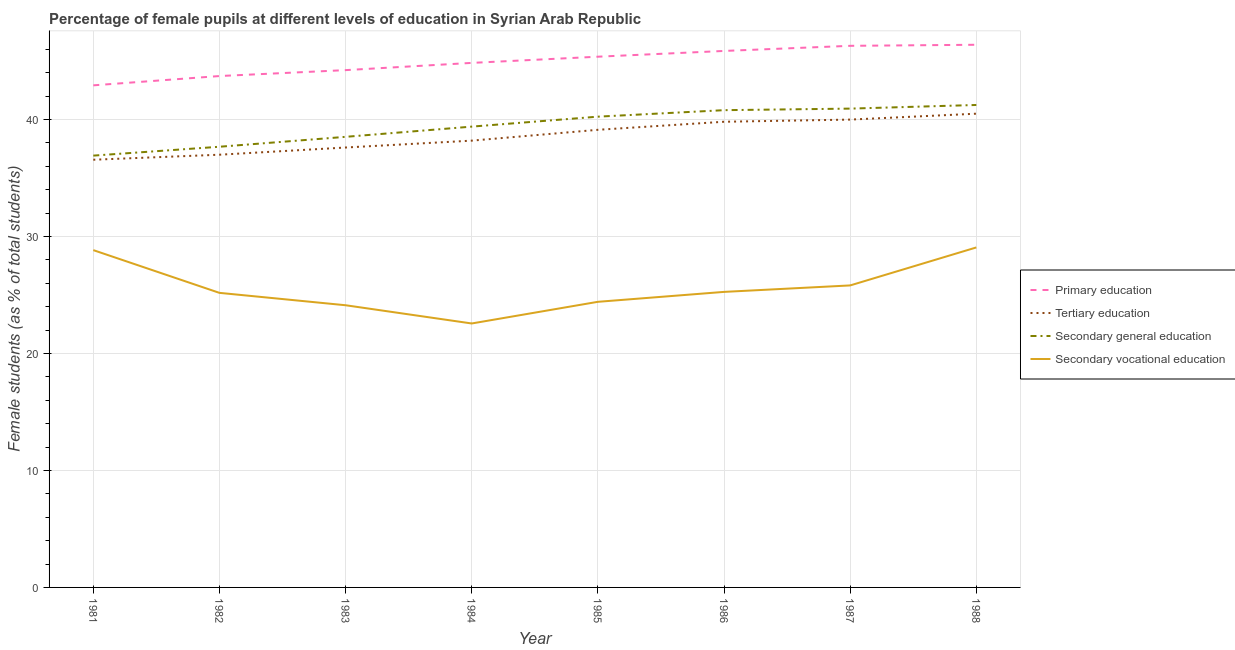Does the line corresponding to percentage of female students in primary education intersect with the line corresponding to percentage of female students in secondary vocational education?
Your answer should be very brief. No. What is the percentage of female students in tertiary education in 1981?
Your response must be concise. 36.56. Across all years, what is the maximum percentage of female students in primary education?
Your answer should be very brief. 46.39. Across all years, what is the minimum percentage of female students in primary education?
Your answer should be compact. 42.92. In which year was the percentage of female students in tertiary education maximum?
Offer a terse response. 1988. In which year was the percentage of female students in secondary vocational education minimum?
Your answer should be compact. 1984. What is the total percentage of female students in tertiary education in the graph?
Provide a succinct answer. 308.75. What is the difference between the percentage of female students in primary education in 1985 and that in 1986?
Provide a succinct answer. -0.49. What is the difference between the percentage of female students in tertiary education in 1981 and the percentage of female students in secondary education in 1987?
Ensure brevity in your answer.  -4.37. What is the average percentage of female students in primary education per year?
Offer a terse response. 44.95. In the year 1984, what is the difference between the percentage of female students in tertiary education and percentage of female students in primary education?
Your answer should be very brief. -6.65. What is the ratio of the percentage of female students in secondary education in 1983 to that in 1988?
Your response must be concise. 0.93. What is the difference between the highest and the second highest percentage of female students in tertiary education?
Offer a very short reply. 0.5. What is the difference between the highest and the lowest percentage of female students in primary education?
Your answer should be very brief. 3.47. In how many years, is the percentage of female students in tertiary education greater than the average percentage of female students in tertiary education taken over all years?
Offer a terse response. 4. Is it the case that in every year, the sum of the percentage of female students in tertiary education and percentage of female students in primary education is greater than the sum of percentage of female students in secondary education and percentage of female students in secondary vocational education?
Your answer should be very brief. No. Does the percentage of female students in secondary vocational education monotonically increase over the years?
Your answer should be compact. No. Is the percentage of female students in primary education strictly greater than the percentage of female students in secondary vocational education over the years?
Give a very brief answer. Yes. Is the percentage of female students in primary education strictly less than the percentage of female students in secondary vocational education over the years?
Ensure brevity in your answer.  No. How many lines are there?
Offer a very short reply. 4. Are the values on the major ticks of Y-axis written in scientific E-notation?
Ensure brevity in your answer.  No. How many legend labels are there?
Keep it short and to the point. 4. How are the legend labels stacked?
Keep it short and to the point. Vertical. What is the title of the graph?
Give a very brief answer. Percentage of female pupils at different levels of education in Syrian Arab Republic. What is the label or title of the X-axis?
Your answer should be compact. Year. What is the label or title of the Y-axis?
Offer a terse response. Female students (as % of total students). What is the Female students (as % of total students) in Primary education in 1981?
Provide a succinct answer. 42.92. What is the Female students (as % of total students) in Tertiary education in 1981?
Make the answer very short. 36.56. What is the Female students (as % of total students) in Secondary general education in 1981?
Provide a short and direct response. 36.91. What is the Female students (as % of total students) in Secondary vocational education in 1981?
Offer a very short reply. 28.83. What is the Female students (as % of total students) in Primary education in 1982?
Provide a short and direct response. 43.71. What is the Female students (as % of total students) in Tertiary education in 1982?
Give a very brief answer. 36.99. What is the Female students (as % of total students) in Secondary general education in 1982?
Give a very brief answer. 37.67. What is the Female students (as % of total students) in Secondary vocational education in 1982?
Give a very brief answer. 25.18. What is the Female students (as % of total students) in Primary education in 1983?
Offer a terse response. 44.22. What is the Female students (as % of total students) of Tertiary education in 1983?
Ensure brevity in your answer.  37.6. What is the Female students (as % of total students) of Secondary general education in 1983?
Provide a short and direct response. 38.52. What is the Female students (as % of total students) in Secondary vocational education in 1983?
Provide a short and direct response. 24.12. What is the Female students (as % of total students) of Primary education in 1984?
Keep it short and to the point. 44.84. What is the Female students (as % of total students) in Tertiary education in 1984?
Your response must be concise. 38.19. What is the Female students (as % of total students) in Secondary general education in 1984?
Your answer should be very brief. 39.39. What is the Female students (as % of total students) of Secondary vocational education in 1984?
Your answer should be compact. 22.56. What is the Female students (as % of total students) in Primary education in 1985?
Make the answer very short. 45.37. What is the Female students (as % of total students) of Tertiary education in 1985?
Make the answer very short. 39.12. What is the Female students (as % of total students) of Secondary general education in 1985?
Make the answer very short. 40.24. What is the Female students (as % of total students) in Secondary vocational education in 1985?
Your answer should be very brief. 24.41. What is the Female students (as % of total students) of Primary education in 1986?
Make the answer very short. 45.86. What is the Female students (as % of total students) in Tertiary education in 1986?
Offer a terse response. 39.81. What is the Female students (as % of total students) in Secondary general education in 1986?
Your answer should be very brief. 40.8. What is the Female students (as % of total students) in Secondary vocational education in 1986?
Ensure brevity in your answer.  25.26. What is the Female students (as % of total students) of Primary education in 1987?
Offer a terse response. 46.3. What is the Female students (as % of total students) in Tertiary education in 1987?
Keep it short and to the point. 39.99. What is the Female students (as % of total students) in Secondary general education in 1987?
Offer a very short reply. 40.93. What is the Female students (as % of total students) in Secondary vocational education in 1987?
Offer a very short reply. 25.82. What is the Female students (as % of total students) of Primary education in 1988?
Your answer should be very brief. 46.39. What is the Female students (as % of total students) in Tertiary education in 1988?
Make the answer very short. 40.5. What is the Female students (as % of total students) in Secondary general education in 1988?
Ensure brevity in your answer.  41.24. What is the Female students (as % of total students) of Secondary vocational education in 1988?
Give a very brief answer. 29.06. Across all years, what is the maximum Female students (as % of total students) of Primary education?
Provide a succinct answer. 46.39. Across all years, what is the maximum Female students (as % of total students) of Tertiary education?
Make the answer very short. 40.5. Across all years, what is the maximum Female students (as % of total students) of Secondary general education?
Offer a very short reply. 41.24. Across all years, what is the maximum Female students (as % of total students) in Secondary vocational education?
Offer a very short reply. 29.06. Across all years, what is the minimum Female students (as % of total students) in Primary education?
Your answer should be compact. 42.92. Across all years, what is the minimum Female students (as % of total students) of Tertiary education?
Your answer should be compact. 36.56. Across all years, what is the minimum Female students (as % of total students) of Secondary general education?
Your answer should be compact. 36.91. Across all years, what is the minimum Female students (as % of total students) in Secondary vocational education?
Your answer should be very brief. 22.56. What is the total Female students (as % of total students) in Primary education in the graph?
Ensure brevity in your answer.  359.6. What is the total Female students (as % of total students) in Tertiary education in the graph?
Your response must be concise. 308.75. What is the total Female students (as % of total students) of Secondary general education in the graph?
Keep it short and to the point. 315.7. What is the total Female students (as % of total students) of Secondary vocational education in the graph?
Your answer should be compact. 205.25. What is the difference between the Female students (as % of total students) of Primary education in 1981 and that in 1982?
Keep it short and to the point. -0.8. What is the difference between the Female students (as % of total students) of Tertiary education in 1981 and that in 1982?
Your answer should be compact. -0.43. What is the difference between the Female students (as % of total students) of Secondary general education in 1981 and that in 1982?
Make the answer very short. -0.76. What is the difference between the Female students (as % of total students) of Secondary vocational education in 1981 and that in 1982?
Keep it short and to the point. 3.65. What is the difference between the Female students (as % of total students) in Primary education in 1981 and that in 1983?
Provide a short and direct response. -1.3. What is the difference between the Female students (as % of total students) in Tertiary education in 1981 and that in 1983?
Keep it short and to the point. -1.04. What is the difference between the Female students (as % of total students) in Secondary general education in 1981 and that in 1983?
Offer a very short reply. -1.61. What is the difference between the Female students (as % of total students) of Secondary vocational education in 1981 and that in 1983?
Give a very brief answer. 4.71. What is the difference between the Female students (as % of total students) of Primary education in 1981 and that in 1984?
Your answer should be compact. -1.92. What is the difference between the Female students (as % of total students) of Tertiary education in 1981 and that in 1984?
Your answer should be very brief. -1.63. What is the difference between the Female students (as % of total students) in Secondary general education in 1981 and that in 1984?
Make the answer very short. -2.48. What is the difference between the Female students (as % of total students) in Secondary vocational education in 1981 and that in 1984?
Offer a very short reply. 6.27. What is the difference between the Female students (as % of total students) of Primary education in 1981 and that in 1985?
Provide a short and direct response. -2.45. What is the difference between the Female students (as % of total students) of Tertiary education in 1981 and that in 1985?
Your answer should be very brief. -2.56. What is the difference between the Female students (as % of total students) in Secondary general education in 1981 and that in 1985?
Provide a short and direct response. -3.33. What is the difference between the Female students (as % of total students) in Secondary vocational education in 1981 and that in 1985?
Your answer should be compact. 4.42. What is the difference between the Female students (as % of total students) of Primary education in 1981 and that in 1986?
Your answer should be very brief. -2.94. What is the difference between the Female students (as % of total students) of Tertiary education in 1981 and that in 1986?
Offer a very short reply. -3.25. What is the difference between the Female students (as % of total students) of Secondary general education in 1981 and that in 1986?
Offer a very short reply. -3.88. What is the difference between the Female students (as % of total students) in Secondary vocational education in 1981 and that in 1986?
Give a very brief answer. 3.57. What is the difference between the Female students (as % of total students) in Primary education in 1981 and that in 1987?
Your response must be concise. -3.38. What is the difference between the Female students (as % of total students) in Tertiary education in 1981 and that in 1987?
Make the answer very short. -3.43. What is the difference between the Female students (as % of total students) in Secondary general education in 1981 and that in 1987?
Ensure brevity in your answer.  -4.02. What is the difference between the Female students (as % of total students) of Secondary vocational education in 1981 and that in 1987?
Your answer should be very brief. 3.02. What is the difference between the Female students (as % of total students) of Primary education in 1981 and that in 1988?
Ensure brevity in your answer.  -3.47. What is the difference between the Female students (as % of total students) of Tertiary education in 1981 and that in 1988?
Provide a short and direct response. -3.94. What is the difference between the Female students (as % of total students) in Secondary general education in 1981 and that in 1988?
Give a very brief answer. -4.33. What is the difference between the Female students (as % of total students) of Secondary vocational education in 1981 and that in 1988?
Give a very brief answer. -0.23. What is the difference between the Female students (as % of total students) of Primary education in 1982 and that in 1983?
Provide a succinct answer. -0.51. What is the difference between the Female students (as % of total students) of Tertiary education in 1982 and that in 1983?
Provide a short and direct response. -0.62. What is the difference between the Female students (as % of total students) of Secondary general education in 1982 and that in 1983?
Your answer should be compact. -0.85. What is the difference between the Female students (as % of total students) in Secondary vocational education in 1982 and that in 1983?
Your answer should be very brief. 1.06. What is the difference between the Female students (as % of total students) of Primary education in 1982 and that in 1984?
Your response must be concise. -1.12. What is the difference between the Female students (as % of total students) of Tertiary education in 1982 and that in 1984?
Your answer should be very brief. -1.2. What is the difference between the Female students (as % of total students) of Secondary general education in 1982 and that in 1984?
Offer a very short reply. -1.72. What is the difference between the Female students (as % of total students) of Secondary vocational education in 1982 and that in 1984?
Your response must be concise. 2.62. What is the difference between the Female students (as % of total students) of Primary education in 1982 and that in 1985?
Give a very brief answer. -1.65. What is the difference between the Female students (as % of total students) in Tertiary education in 1982 and that in 1985?
Provide a succinct answer. -2.13. What is the difference between the Female students (as % of total students) of Secondary general education in 1982 and that in 1985?
Provide a succinct answer. -2.57. What is the difference between the Female students (as % of total students) in Secondary vocational education in 1982 and that in 1985?
Keep it short and to the point. 0.77. What is the difference between the Female students (as % of total students) of Primary education in 1982 and that in 1986?
Provide a short and direct response. -2.15. What is the difference between the Female students (as % of total students) in Tertiary education in 1982 and that in 1986?
Make the answer very short. -2.82. What is the difference between the Female students (as % of total students) of Secondary general education in 1982 and that in 1986?
Offer a terse response. -3.13. What is the difference between the Female students (as % of total students) in Secondary vocational education in 1982 and that in 1986?
Your answer should be very brief. -0.08. What is the difference between the Female students (as % of total students) in Primary education in 1982 and that in 1987?
Make the answer very short. -2.58. What is the difference between the Female students (as % of total students) in Tertiary education in 1982 and that in 1987?
Your answer should be compact. -3. What is the difference between the Female students (as % of total students) of Secondary general education in 1982 and that in 1987?
Offer a terse response. -3.26. What is the difference between the Female students (as % of total students) in Secondary vocational education in 1982 and that in 1987?
Provide a succinct answer. -0.64. What is the difference between the Female students (as % of total students) in Primary education in 1982 and that in 1988?
Your response must be concise. -2.67. What is the difference between the Female students (as % of total students) of Tertiary education in 1982 and that in 1988?
Offer a very short reply. -3.51. What is the difference between the Female students (as % of total students) in Secondary general education in 1982 and that in 1988?
Your answer should be very brief. -3.57. What is the difference between the Female students (as % of total students) in Secondary vocational education in 1982 and that in 1988?
Provide a short and direct response. -3.88. What is the difference between the Female students (as % of total students) of Primary education in 1983 and that in 1984?
Make the answer very short. -0.62. What is the difference between the Female students (as % of total students) of Tertiary education in 1983 and that in 1984?
Offer a terse response. -0.59. What is the difference between the Female students (as % of total students) in Secondary general education in 1983 and that in 1984?
Your answer should be very brief. -0.87. What is the difference between the Female students (as % of total students) in Secondary vocational education in 1983 and that in 1984?
Provide a succinct answer. 1.56. What is the difference between the Female students (as % of total students) in Primary education in 1983 and that in 1985?
Keep it short and to the point. -1.15. What is the difference between the Female students (as % of total students) in Tertiary education in 1983 and that in 1985?
Your answer should be very brief. -1.51. What is the difference between the Female students (as % of total students) of Secondary general education in 1983 and that in 1985?
Provide a succinct answer. -1.72. What is the difference between the Female students (as % of total students) in Secondary vocational education in 1983 and that in 1985?
Make the answer very short. -0.29. What is the difference between the Female students (as % of total students) of Primary education in 1983 and that in 1986?
Ensure brevity in your answer.  -1.64. What is the difference between the Female students (as % of total students) of Tertiary education in 1983 and that in 1986?
Make the answer very short. -2.2. What is the difference between the Female students (as % of total students) of Secondary general education in 1983 and that in 1986?
Keep it short and to the point. -2.28. What is the difference between the Female students (as % of total students) in Secondary vocational education in 1983 and that in 1986?
Provide a short and direct response. -1.14. What is the difference between the Female students (as % of total students) of Primary education in 1983 and that in 1987?
Offer a very short reply. -2.08. What is the difference between the Female students (as % of total students) of Tertiary education in 1983 and that in 1987?
Make the answer very short. -2.39. What is the difference between the Female students (as % of total students) in Secondary general education in 1983 and that in 1987?
Ensure brevity in your answer.  -2.41. What is the difference between the Female students (as % of total students) in Secondary vocational education in 1983 and that in 1987?
Make the answer very short. -1.69. What is the difference between the Female students (as % of total students) in Primary education in 1983 and that in 1988?
Give a very brief answer. -2.17. What is the difference between the Female students (as % of total students) in Tertiary education in 1983 and that in 1988?
Provide a succinct answer. -2.89. What is the difference between the Female students (as % of total students) in Secondary general education in 1983 and that in 1988?
Your response must be concise. -2.72. What is the difference between the Female students (as % of total students) in Secondary vocational education in 1983 and that in 1988?
Your response must be concise. -4.94. What is the difference between the Female students (as % of total students) of Primary education in 1984 and that in 1985?
Offer a terse response. -0.53. What is the difference between the Female students (as % of total students) in Tertiary education in 1984 and that in 1985?
Your answer should be compact. -0.93. What is the difference between the Female students (as % of total students) in Secondary general education in 1984 and that in 1985?
Your answer should be compact. -0.85. What is the difference between the Female students (as % of total students) of Secondary vocational education in 1984 and that in 1985?
Provide a succinct answer. -1.85. What is the difference between the Female students (as % of total students) of Primary education in 1984 and that in 1986?
Keep it short and to the point. -1.02. What is the difference between the Female students (as % of total students) in Tertiary education in 1984 and that in 1986?
Keep it short and to the point. -1.61. What is the difference between the Female students (as % of total students) in Secondary general education in 1984 and that in 1986?
Offer a terse response. -1.41. What is the difference between the Female students (as % of total students) of Secondary vocational education in 1984 and that in 1986?
Your answer should be very brief. -2.7. What is the difference between the Female students (as % of total students) of Primary education in 1984 and that in 1987?
Make the answer very short. -1.46. What is the difference between the Female students (as % of total students) of Tertiary education in 1984 and that in 1987?
Provide a short and direct response. -1.8. What is the difference between the Female students (as % of total students) in Secondary general education in 1984 and that in 1987?
Your answer should be very brief. -1.54. What is the difference between the Female students (as % of total students) of Secondary vocational education in 1984 and that in 1987?
Provide a succinct answer. -3.25. What is the difference between the Female students (as % of total students) of Primary education in 1984 and that in 1988?
Offer a terse response. -1.55. What is the difference between the Female students (as % of total students) of Tertiary education in 1984 and that in 1988?
Make the answer very short. -2.3. What is the difference between the Female students (as % of total students) in Secondary general education in 1984 and that in 1988?
Provide a succinct answer. -1.85. What is the difference between the Female students (as % of total students) in Secondary vocational education in 1984 and that in 1988?
Give a very brief answer. -6.5. What is the difference between the Female students (as % of total students) of Primary education in 1985 and that in 1986?
Offer a terse response. -0.49. What is the difference between the Female students (as % of total students) of Tertiary education in 1985 and that in 1986?
Your answer should be very brief. -0.69. What is the difference between the Female students (as % of total students) in Secondary general education in 1985 and that in 1986?
Offer a terse response. -0.55. What is the difference between the Female students (as % of total students) of Secondary vocational education in 1985 and that in 1986?
Offer a terse response. -0.85. What is the difference between the Female students (as % of total students) of Primary education in 1985 and that in 1987?
Provide a short and direct response. -0.93. What is the difference between the Female students (as % of total students) of Tertiary education in 1985 and that in 1987?
Provide a short and direct response. -0.87. What is the difference between the Female students (as % of total students) in Secondary general education in 1985 and that in 1987?
Your response must be concise. -0.69. What is the difference between the Female students (as % of total students) of Secondary vocational education in 1985 and that in 1987?
Your response must be concise. -1.4. What is the difference between the Female students (as % of total students) in Primary education in 1985 and that in 1988?
Ensure brevity in your answer.  -1.02. What is the difference between the Female students (as % of total students) of Tertiary education in 1985 and that in 1988?
Keep it short and to the point. -1.38. What is the difference between the Female students (as % of total students) in Secondary general education in 1985 and that in 1988?
Ensure brevity in your answer.  -1. What is the difference between the Female students (as % of total students) of Secondary vocational education in 1985 and that in 1988?
Provide a short and direct response. -4.65. What is the difference between the Female students (as % of total students) in Primary education in 1986 and that in 1987?
Keep it short and to the point. -0.44. What is the difference between the Female students (as % of total students) in Tertiary education in 1986 and that in 1987?
Give a very brief answer. -0.18. What is the difference between the Female students (as % of total students) of Secondary general education in 1986 and that in 1987?
Your answer should be very brief. -0.13. What is the difference between the Female students (as % of total students) in Secondary vocational education in 1986 and that in 1987?
Give a very brief answer. -0.55. What is the difference between the Female students (as % of total students) of Primary education in 1986 and that in 1988?
Offer a very short reply. -0.53. What is the difference between the Female students (as % of total students) in Tertiary education in 1986 and that in 1988?
Your answer should be compact. -0.69. What is the difference between the Female students (as % of total students) in Secondary general education in 1986 and that in 1988?
Keep it short and to the point. -0.44. What is the difference between the Female students (as % of total students) in Secondary vocational education in 1986 and that in 1988?
Provide a succinct answer. -3.8. What is the difference between the Female students (as % of total students) of Primary education in 1987 and that in 1988?
Offer a terse response. -0.09. What is the difference between the Female students (as % of total students) in Tertiary education in 1987 and that in 1988?
Keep it short and to the point. -0.5. What is the difference between the Female students (as % of total students) in Secondary general education in 1987 and that in 1988?
Make the answer very short. -0.31. What is the difference between the Female students (as % of total students) of Secondary vocational education in 1987 and that in 1988?
Offer a very short reply. -3.25. What is the difference between the Female students (as % of total students) in Primary education in 1981 and the Female students (as % of total students) in Tertiary education in 1982?
Give a very brief answer. 5.93. What is the difference between the Female students (as % of total students) in Primary education in 1981 and the Female students (as % of total students) in Secondary general education in 1982?
Give a very brief answer. 5.25. What is the difference between the Female students (as % of total students) in Primary education in 1981 and the Female students (as % of total students) in Secondary vocational education in 1982?
Make the answer very short. 17.74. What is the difference between the Female students (as % of total students) of Tertiary education in 1981 and the Female students (as % of total students) of Secondary general education in 1982?
Offer a very short reply. -1.11. What is the difference between the Female students (as % of total students) of Tertiary education in 1981 and the Female students (as % of total students) of Secondary vocational education in 1982?
Keep it short and to the point. 11.38. What is the difference between the Female students (as % of total students) of Secondary general education in 1981 and the Female students (as % of total students) of Secondary vocational education in 1982?
Offer a terse response. 11.73. What is the difference between the Female students (as % of total students) in Primary education in 1981 and the Female students (as % of total students) in Tertiary education in 1983?
Make the answer very short. 5.31. What is the difference between the Female students (as % of total students) in Primary education in 1981 and the Female students (as % of total students) in Secondary general education in 1983?
Your answer should be compact. 4.4. What is the difference between the Female students (as % of total students) in Primary education in 1981 and the Female students (as % of total students) in Secondary vocational education in 1983?
Your response must be concise. 18.8. What is the difference between the Female students (as % of total students) of Tertiary education in 1981 and the Female students (as % of total students) of Secondary general education in 1983?
Keep it short and to the point. -1.96. What is the difference between the Female students (as % of total students) of Tertiary education in 1981 and the Female students (as % of total students) of Secondary vocational education in 1983?
Provide a succinct answer. 12.44. What is the difference between the Female students (as % of total students) of Secondary general education in 1981 and the Female students (as % of total students) of Secondary vocational education in 1983?
Offer a very short reply. 12.79. What is the difference between the Female students (as % of total students) of Primary education in 1981 and the Female students (as % of total students) of Tertiary education in 1984?
Keep it short and to the point. 4.73. What is the difference between the Female students (as % of total students) in Primary education in 1981 and the Female students (as % of total students) in Secondary general education in 1984?
Give a very brief answer. 3.53. What is the difference between the Female students (as % of total students) of Primary education in 1981 and the Female students (as % of total students) of Secondary vocational education in 1984?
Provide a short and direct response. 20.36. What is the difference between the Female students (as % of total students) in Tertiary education in 1981 and the Female students (as % of total students) in Secondary general education in 1984?
Offer a terse response. -2.83. What is the difference between the Female students (as % of total students) of Tertiary education in 1981 and the Female students (as % of total students) of Secondary vocational education in 1984?
Your answer should be very brief. 14. What is the difference between the Female students (as % of total students) of Secondary general education in 1981 and the Female students (as % of total students) of Secondary vocational education in 1984?
Offer a terse response. 14.35. What is the difference between the Female students (as % of total students) of Primary education in 1981 and the Female students (as % of total students) of Tertiary education in 1985?
Ensure brevity in your answer.  3.8. What is the difference between the Female students (as % of total students) of Primary education in 1981 and the Female students (as % of total students) of Secondary general education in 1985?
Offer a terse response. 2.68. What is the difference between the Female students (as % of total students) in Primary education in 1981 and the Female students (as % of total students) in Secondary vocational education in 1985?
Your answer should be very brief. 18.5. What is the difference between the Female students (as % of total students) in Tertiary education in 1981 and the Female students (as % of total students) in Secondary general education in 1985?
Your answer should be compact. -3.68. What is the difference between the Female students (as % of total students) in Tertiary education in 1981 and the Female students (as % of total students) in Secondary vocational education in 1985?
Provide a succinct answer. 12.15. What is the difference between the Female students (as % of total students) of Secondary general education in 1981 and the Female students (as % of total students) of Secondary vocational education in 1985?
Offer a terse response. 12.5. What is the difference between the Female students (as % of total students) of Primary education in 1981 and the Female students (as % of total students) of Tertiary education in 1986?
Provide a succinct answer. 3.11. What is the difference between the Female students (as % of total students) of Primary education in 1981 and the Female students (as % of total students) of Secondary general education in 1986?
Your answer should be compact. 2.12. What is the difference between the Female students (as % of total students) in Primary education in 1981 and the Female students (as % of total students) in Secondary vocational education in 1986?
Offer a terse response. 17.66. What is the difference between the Female students (as % of total students) of Tertiary education in 1981 and the Female students (as % of total students) of Secondary general education in 1986?
Your response must be concise. -4.24. What is the difference between the Female students (as % of total students) of Tertiary education in 1981 and the Female students (as % of total students) of Secondary vocational education in 1986?
Your response must be concise. 11.3. What is the difference between the Female students (as % of total students) in Secondary general education in 1981 and the Female students (as % of total students) in Secondary vocational education in 1986?
Make the answer very short. 11.65. What is the difference between the Female students (as % of total students) of Primary education in 1981 and the Female students (as % of total students) of Tertiary education in 1987?
Your response must be concise. 2.93. What is the difference between the Female students (as % of total students) in Primary education in 1981 and the Female students (as % of total students) in Secondary general education in 1987?
Your response must be concise. 1.99. What is the difference between the Female students (as % of total students) of Primary education in 1981 and the Female students (as % of total students) of Secondary vocational education in 1987?
Your answer should be very brief. 17.1. What is the difference between the Female students (as % of total students) in Tertiary education in 1981 and the Female students (as % of total students) in Secondary general education in 1987?
Give a very brief answer. -4.37. What is the difference between the Female students (as % of total students) in Tertiary education in 1981 and the Female students (as % of total students) in Secondary vocational education in 1987?
Give a very brief answer. 10.74. What is the difference between the Female students (as % of total students) in Secondary general education in 1981 and the Female students (as % of total students) in Secondary vocational education in 1987?
Keep it short and to the point. 11.1. What is the difference between the Female students (as % of total students) in Primary education in 1981 and the Female students (as % of total students) in Tertiary education in 1988?
Provide a succinct answer. 2.42. What is the difference between the Female students (as % of total students) of Primary education in 1981 and the Female students (as % of total students) of Secondary general education in 1988?
Make the answer very short. 1.68. What is the difference between the Female students (as % of total students) of Primary education in 1981 and the Female students (as % of total students) of Secondary vocational education in 1988?
Keep it short and to the point. 13.86. What is the difference between the Female students (as % of total students) in Tertiary education in 1981 and the Female students (as % of total students) in Secondary general education in 1988?
Offer a terse response. -4.68. What is the difference between the Female students (as % of total students) in Tertiary education in 1981 and the Female students (as % of total students) in Secondary vocational education in 1988?
Your response must be concise. 7.5. What is the difference between the Female students (as % of total students) in Secondary general education in 1981 and the Female students (as % of total students) in Secondary vocational education in 1988?
Make the answer very short. 7.85. What is the difference between the Female students (as % of total students) of Primary education in 1982 and the Female students (as % of total students) of Tertiary education in 1983?
Provide a short and direct response. 6.11. What is the difference between the Female students (as % of total students) in Primary education in 1982 and the Female students (as % of total students) in Secondary general education in 1983?
Provide a succinct answer. 5.2. What is the difference between the Female students (as % of total students) in Primary education in 1982 and the Female students (as % of total students) in Secondary vocational education in 1983?
Make the answer very short. 19.59. What is the difference between the Female students (as % of total students) in Tertiary education in 1982 and the Female students (as % of total students) in Secondary general education in 1983?
Your response must be concise. -1.53. What is the difference between the Female students (as % of total students) of Tertiary education in 1982 and the Female students (as % of total students) of Secondary vocational education in 1983?
Provide a succinct answer. 12.87. What is the difference between the Female students (as % of total students) of Secondary general education in 1982 and the Female students (as % of total students) of Secondary vocational education in 1983?
Offer a very short reply. 13.55. What is the difference between the Female students (as % of total students) of Primary education in 1982 and the Female students (as % of total students) of Tertiary education in 1984?
Provide a short and direct response. 5.52. What is the difference between the Female students (as % of total students) of Primary education in 1982 and the Female students (as % of total students) of Secondary general education in 1984?
Your answer should be very brief. 4.32. What is the difference between the Female students (as % of total students) in Primary education in 1982 and the Female students (as % of total students) in Secondary vocational education in 1984?
Make the answer very short. 21.15. What is the difference between the Female students (as % of total students) of Tertiary education in 1982 and the Female students (as % of total students) of Secondary general education in 1984?
Make the answer very short. -2.4. What is the difference between the Female students (as % of total students) in Tertiary education in 1982 and the Female students (as % of total students) in Secondary vocational education in 1984?
Offer a terse response. 14.43. What is the difference between the Female students (as % of total students) of Secondary general education in 1982 and the Female students (as % of total students) of Secondary vocational education in 1984?
Make the answer very short. 15.11. What is the difference between the Female students (as % of total students) in Primary education in 1982 and the Female students (as % of total students) in Tertiary education in 1985?
Provide a short and direct response. 4.6. What is the difference between the Female students (as % of total students) in Primary education in 1982 and the Female students (as % of total students) in Secondary general education in 1985?
Your answer should be very brief. 3.47. What is the difference between the Female students (as % of total students) in Primary education in 1982 and the Female students (as % of total students) in Secondary vocational education in 1985?
Provide a short and direct response. 19.3. What is the difference between the Female students (as % of total students) of Tertiary education in 1982 and the Female students (as % of total students) of Secondary general education in 1985?
Ensure brevity in your answer.  -3.25. What is the difference between the Female students (as % of total students) of Tertiary education in 1982 and the Female students (as % of total students) of Secondary vocational education in 1985?
Ensure brevity in your answer.  12.57. What is the difference between the Female students (as % of total students) of Secondary general education in 1982 and the Female students (as % of total students) of Secondary vocational education in 1985?
Ensure brevity in your answer.  13.26. What is the difference between the Female students (as % of total students) in Primary education in 1982 and the Female students (as % of total students) in Tertiary education in 1986?
Your answer should be very brief. 3.91. What is the difference between the Female students (as % of total students) in Primary education in 1982 and the Female students (as % of total students) in Secondary general education in 1986?
Make the answer very short. 2.92. What is the difference between the Female students (as % of total students) in Primary education in 1982 and the Female students (as % of total students) in Secondary vocational education in 1986?
Ensure brevity in your answer.  18.45. What is the difference between the Female students (as % of total students) of Tertiary education in 1982 and the Female students (as % of total students) of Secondary general education in 1986?
Provide a short and direct response. -3.81. What is the difference between the Female students (as % of total students) of Tertiary education in 1982 and the Female students (as % of total students) of Secondary vocational education in 1986?
Provide a short and direct response. 11.73. What is the difference between the Female students (as % of total students) in Secondary general education in 1982 and the Female students (as % of total students) in Secondary vocational education in 1986?
Offer a terse response. 12.41. What is the difference between the Female students (as % of total students) in Primary education in 1982 and the Female students (as % of total students) in Tertiary education in 1987?
Provide a short and direct response. 3.72. What is the difference between the Female students (as % of total students) of Primary education in 1982 and the Female students (as % of total students) of Secondary general education in 1987?
Make the answer very short. 2.78. What is the difference between the Female students (as % of total students) in Primary education in 1982 and the Female students (as % of total students) in Secondary vocational education in 1987?
Your response must be concise. 17.9. What is the difference between the Female students (as % of total students) of Tertiary education in 1982 and the Female students (as % of total students) of Secondary general education in 1987?
Offer a very short reply. -3.94. What is the difference between the Female students (as % of total students) of Tertiary education in 1982 and the Female students (as % of total students) of Secondary vocational education in 1987?
Keep it short and to the point. 11.17. What is the difference between the Female students (as % of total students) in Secondary general education in 1982 and the Female students (as % of total students) in Secondary vocational education in 1987?
Provide a succinct answer. 11.85. What is the difference between the Female students (as % of total students) in Primary education in 1982 and the Female students (as % of total students) in Tertiary education in 1988?
Your answer should be very brief. 3.22. What is the difference between the Female students (as % of total students) in Primary education in 1982 and the Female students (as % of total students) in Secondary general education in 1988?
Provide a short and direct response. 2.47. What is the difference between the Female students (as % of total students) of Primary education in 1982 and the Female students (as % of total students) of Secondary vocational education in 1988?
Ensure brevity in your answer.  14.65. What is the difference between the Female students (as % of total students) of Tertiary education in 1982 and the Female students (as % of total students) of Secondary general education in 1988?
Ensure brevity in your answer.  -4.25. What is the difference between the Female students (as % of total students) in Tertiary education in 1982 and the Female students (as % of total students) in Secondary vocational education in 1988?
Your answer should be compact. 7.93. What is the difference between the Female students (as % of total students) in Secondary general education in 1982 and the Female students (as % of total students) in Secondary vocational education in 1988?
Provide a succinct answer. 8.61. What is the difference between the Female students (as % of total students) in Primary education in 1983 and the Female students (as % of total students) in Tertiary education in 1984?
Your response must be concise. 6.03. What is the difference between the Female students (as % of total students) in Primary education in 1983 and the Female students (as % of total students) in Secondary general education in 1984?
Your response must be concise. 4.83. What is the difference between the Female students (as % of total students) of Primary education in 1983 and the Female students (as % of total students) of Secondary vocational education in 1984?
Your answer should be very brief. 21.66. What is the difference between the Female students (as % of total students) of Tertiary education in 1983 and the Female students (as % of total students) of Secondary general education in 1984?
Ensure brevity in your answer.  -1.79. What is the difference between the Female students (as % of total students) of Tertiary education in 1983 and the Female students (as % of total students) of Secondary vocational education in 1984?
Keep it short and to the point. 15.04. What is the difference between the Female students (as % of total students) in Secondary general education in 1983 and the Female students (as % of total students) in Secondary vocational education in 1984?
Your answer should be compact. 15.95. What is the difference between the Female students (as % of total students) of Primary education in 1983 and the Female students (as % of total students) of Tertiary education in 1985?
Provide a short and direct response. 5.1. What is the difference between the Female students (as % of total students) of Primary education in 1983 and the Female students (as % of total students) of Secondary general education in 1985?
Keep it short and to the point. 3.98. What is the difference between the Female students (as % of total students) of Primary education in 1983 and the Female students (as % of total students) of Secondary vocational education in 1985?
Give a very brief answer. 19.81. What is the difference between the Female students (as % of total students) in Tertiary education in 1983 and the Female students (as % of total students) in Secondary general education in 1985?
Your answer should be compact. -2.64. What is the difference between the Female students (as % of total students) of Tertiary education in 1983 and the Female students (as % of total students) of Secondary vocational education in 1985?
Offer a very short reply. 13.19. What is the difference between the Female students (as % of total students) in Secondary general education in 1983 and the Female students (as % of total students) in Secondary vocational education in 1985?
Make the answer very short. 14.1. What is the difference between the Female students (as % of total students) in Primary education in 1983 and the Female students (as % of total students) in Tertiary education in 1986?
Your response must be concise. 4.41. What is the difference between the Female students (as % of total students) of Primary education in 1983 and the Female students (as % of total students) of Secondary general education in 1986?
Provide a succinct answer. 3.42. What is the difference between the Female students (as % of total students) in Primary education in 1983 and the Female students (as % of total students) in Secondary vocational education in 1986?
Offer a terse response. 18.96. What is the difference between the Female students (as % of total students) of Tertiary education in 1983 and the Female students (as % of total students) of Secondary general education in 1986?
Your answer should be compact. -3.19. What is the difference between the Female students (as % of total students) in Tertiary education in 1983 and the Female students (as % of total students) in Secondary vocational education in 1986?
Your answer should be compact. 12.34. What is the difference between the Female students (as % of total students) of Secondary general education in 1983 and the Female students (as % of total students) of Secondary vocational education in 1986?
Provide a succinct answer. 13.25. What is the difference between the Female students (as % of total students) in Primary education in 1983 and the Female students (as % of total students) in Tertiary education in 1987?
Your response must be concise. 4.23. What is the difference between the Female students (as % of total students) of Primary education in 1983 and the Female students (as % of total students) of Secondary general education in 1987?
Ensure brevity in your answer.  3.29. What is the difference between the Female students (as % of total students) in Primary education in 1983 and the Female students (as % of total students) in Secondary vocational education in 1987?
Ensure brevity in your answer.  18.4. What is the difference between the Female students (as % of total students) of Tertiary education in 1983 and the Female students (as % of total students) of Secondary general education in 1987?
Make the answer very short. -3.33. What is the difference between the Female students (as % of total students) in Tertiary education in 1983 and the Female students (as % of total students) in Secondary vocational education in 1987?
Offer a very short reply. 11.79. What is the difference between the Female students (as % of total students) of Secondary general education in 1983 and the Female students (as % of total students) of Secondary vocational education in 1987?
Ensure brevity in your answer.  12.7. What is the difference between the Female students (as % of total students) in Primary education in 1983 and the Female students (as % of total students) in Tertiary education in 1988?
Ensure brevity in your answer.  3.72. What is the difference between the Female students (as % of total students) of Primary education in 1983 and the Female students (as % of total students) of Secondary general education in 1988?
Your answer should be very brief. 2.98. What is the difference between the Female students (as % of total students) in Primary education in 1983 and the Female students (as % of total students) in Secondary vocational education in 1988?
Give a very brief answer. 15.16. What is the difference between the Female students (as % of total students) in Tertiary education in 1983 and the Female students (as % of total students) in Secondary general education in 1988?
Your response must be concise. -3.64. What is the difference between the Female students (as % of total students) of Tertiary education in 1983 and the Female students (as % of total students) of Secondary vocational education in 1988?
Give a very brief answer. 8.54. What is the difference between the Female students (as % of total students) of Secondary general education in 1983 and the Female students (as % of total students) of Secondary vocational education in 1988?
Provide a succinct answer. 9.45. What is the difference between the Female students (as % of total students) of Primary education in 1984 and the Female students (as % of total students) of Tertiary education in 1985?
Offer a terse response. 5.72. What is the difference between the Female students (as % of total students) in Primary education in 1984 and the Female students (as % of total students) in Secondary general education in 1985?
Make the answer very short. 4.6. What is the difference between the Female students (as % of total students) in Primary education in 1984 and the Female students (as % of total students) in Secondary vocational education in 1985?
Provide a succinct answer. 20.42. What is the difference between the Female students (as % of total students) in Tertiary education in 1984 and the Female students (as % of total students) in Secondary general education in 1985?
Provide a short and direct response. -2.05. What is the difference between the Female students (as % of total students) in Tertiary education in 1984 and the Female students (as % of total students) in Secondary vocational education in 1985?
Offer a very short reply. 13.78. What is the difference between the Female students (as % of total students) in Secondary general education in 1984 and the Female students (as % of total students) in Secondary vocational education in 1985?
Give a very brief answer. 14.98. What is the difference between the Female students (as % of total students) in Primary education in 1984 and the Female students (as % of total students) in Tertiary education in 1986?
Make the answer very short. 5.03. What is the difference between the Female students (as % of total students) of Primary education in 1984 and the Female students (as % of total students) of Secondary general education in 1986?
Offer a very short reply. 4.04. What is the difference between the Female students (as % of total students) of Primary education in 1984 and the Female students (as % of total students) of Secondary vocational education in 1986?
Give a very brief answer. 19.58. What is the difference between the Female students (as % of total students) of Tertiary education in 1984 and the Female students (as % of total students) of Secondary general education in 1986?
Your answer should be very brief. -2.6. What is the difference between the Female students (as % of total students) in Tertiary education in 1984 and the Female students (as % of total students) in Secondary vocational education in 1986?
Offer a very short reply. 12.93. What is the difference between the Female students (as % of total students) of Secondary general education in 1984 and the Female students (as % of total students) of Secondary vocational education in 1986?
Make the answer very short. 14.13. What is the difference between the Female students (as % of total students) in Primary education in 1984 and the Female students (as % of total students) in Tertiary education in 1987?
Ensure brevity in your answer.  4.85. What is the difference between the Female students (as % of total students) of Primary education in 1984 and the Female students (as % of total students) of Secondary general education in 1987?
Keep it short and to the point. 3.91. What is the difference between the Female students (as % of total students) of Primary education in 1984 and the Female students (as % of total students) of Secondary vocational education in 1987?
Offer a terse response. 19.02. What is the difference between the Female students (as % of total students) of Tertiary education in 1984 and the Female students (as % of total students) of Secondary general education in 1987?
Keep it short and to the point. -2.74. What is the difference between the Female students (as % of total students) in Tertiary education in 1984 and the Female students (as % of total students) in Secondary vocational education in 1987?
Make the answer very short. 12.38. What is the difference between the Female students (as % of total students) in Secondary general education in 1984 and the Female students (as % of total students) in Secondary vocational education in 1987?
Provide a succinct answer. 13.57. What is the difference between the Female students (as % of total students) in Primary education in 1984 and the Female students (as % of total students) in Tertiary education in 1988?
Offer a terse response. 4.34. What is the difference between the Female students (as % of total students) of Primary education in 1984 and the Female students (as % of total students) of Secondary general education in 1988?
Make the answer very short. 3.6. What is the difference between the Female students (as % of total students) of Primary education in 1984 and the Female students (as % of total students) of Secondary vocational education in 1988?
Provide a short and direct response. 15.78. What is the difference between the Female students (as % of total students) in Tertiary education in 1984 and the Female students (as % of total students) in Secondary general education in 1988?
Keep it short and to the point. -3.05. What is the difference between the Female students (as % of total students) of Tertiary education in 1984 and the Female students (as % of total students) of Secondary vocational education in 1988?
Keep it short and to the point. 9.13. What is the difference between the Female students (as % of total students) in Secondary general education in 1984 and the Female students (as % of total students) in Secondary vocational education in 1988?
Your answer should be compact. 10.33. What is the difference between the Female students (as % of total students) in Primary education in 1985 and the Female students (as % of total students) in Tertiary education in 1986?
Provide a succinct answer. 5.56. What is the difference between the Female students (as % of total students) in Primary education in 1985 and the Female students (as % of total students) in Secondary general education in 1986?
Offer a terse response. 4.57. What is the difference between the Female students (as % of total students) of Primary education in 1985 and the Female students (as % of total students) of Secondary vocational education in 1986?
Keep it short and to the point. 20.1. What is the difference between the Female students (as % of total students) in Tertiary education in 1985 and the Female students (as % of total students) in Secondary general education in 1986?
Provide a short and direct response. -1.68. What is the difference between the Female students (as % of total students) of Tertiary education in 1985 and the Female students (as % of total students) of Secondary vocational education in 1986?
Provide a succinct answer. 13.86. What is the difference between the Female students (as % of total students) in Secondary general education in 1985 and the Female students (as % of total students) in Secondary vocational education in 1986?
Offer a terse response. 14.98. What is the difference between the Female students (as % of total students) of Primary education in 1985 and the Female students (as % of total students) of Tertiary education in 1987?
Ensure brevity in your answer.  5.38. What is the difference between the Female students (as % of total students) of Primary education in 1985 and the Female students (as % of total students) of Secondary general education in 1987?
Provide a short and direct response. 4.44. What is the difference between the Female students (as % of total students) in Primary education in 1985 and the Female students (as % of total students) in Secondary vocational education in 1987?
Keep it short and to the point. 19.55. What is the difference between the Female students (as % of total students) in Tertiary education in 1985 and the Female students (as % of total students) in Secondary general education in 1987?
Offer a terse response. -1.81. What is the difference between the Female students (as % of total students) of Tertiary education in 1985 and the Female students (as % of total students) of Secondary vocational education in 1987?
Provide a succinct answer. 13.3. What is the difference between the Female students (as % of total students) of Secondary general education in 1985 and the Female students (as % of total students) of Secondary vocational education in 1987?
Give a very brief answer. 14.43. What is the difference between the Female students (as % of total students) in Primary education in 1985 and the Female students (as % of total students) in Tertiary education in 1988?
Provide a short and direct response. 4.87. What is the difference between the Female students (as % of total students) of Primary education in 1985 and the Female students (as % of total students) of Secondary general education in 1988?
Offer a terse response. 4.13. What is the difference between the Female students (as % of total students) in Primary education in 1985 and the Female students (as % of total students) in Secondary vocational education in 1988?
Keep it short and to the point. 16.3. What is the difference between the Female students (as % of total students) of Tertiary education in 1985 and the Female students (as % of total students) of Secondary general education in 1988?
Offer a terse response. -2.12. What is the difference between the Female students (as % of total students) of Tertiary education in 1985 and the Female students (as % of total students) of Secondary vocational education in 1988?
Provide a succinct answer. 10.06. What is the difference between the Female students (as % of total students) in Secondary general education in 1985 and the Female students (as % of total students) in Secondary vocational education in 1988?
Offer a very short reply. 11.18. What is the difference between the Female students (as % of total students) of Primary education in 1986 and the Female students (as % of total students) of Tertiary education in 1987?
Ensure brevity in your answer.  5.87. What is the difference between the Female students (as % of total students) of Primary education in 1986 and the Female students (as % of total students) of Secondary general education in 1987?
Offer a terse response. 4.93. What is the difference between the Female students (as % of total students) in Primary education in 1986 and the Female students (as % of total students) in Secondary vocational education in 1987?
Provide a short and direct response. 20.04. What is the difference between the Female students (as % of total students) of Tertiary education in 1986 and the Female students (as % of total students) of Secondary general education in 1987?
Provide a succinct answer. -1.12. What is the difference between the Female students (as % of total students) in Tertiary education in 1986 and the Female students (as % of total students) in Secondary vocational education in 1987?
Ensure brevity in your answer.  13.99. What is the difference between the Female students (as % of total students) in Secondary general education in 1986 and the Female students (as % of total students) in Secondary vocational education in 1987?
Make the answer very short. 14.98. What is the difference between the Female students (as % of total students) in Primary education in 1986 and the Female students (as % of total students) in Tertiary education in 1988?
Ensure brevity in your answer.  5.36. What is the difference between the Female students (as % of total students) in Primary education in 1986 and the Female students (as % of total students) in Secondary general education in 1988?
Make the answer very short. 4.62. What is the difference between the Female students (as % of total students) of Primary education in 1986 and the Female students (as % of total students) of Secondary vocational education in 1988?
Your response must be concise. 16.8. What is the difference between the Female students (as % of total students) in Tertiary education in 1986 and the Female students (as % of total students) in Secondary general education in 1988?
Your response must be concise. -1.43. What is the difference between the Female students (as % of total students) in Tertiary education in 1986 and the Female students (as % of total students) in Secondary vocational education in 1988?
Offer a very short reply. 10.74. What is the difference between the Female students (as % of total students) of Secondary general education in 1986 and the Female students (as % of total students) of Secondary vocational education in 1988?
Provide a succinct answer. 11.73. What is the difference between the Female students (as % of total students) of Primary education in 1987 and the Female students (as % of total students) of Tertiary education in 1988?
Your answer should be compact. 5.8. What is the difference between the Female students (as % of total students) in Primary education in 1987 and the Female students (as % of total students) in Secondary general education in 1988?
Keep it short and to the point. 5.06. What is the difference between the Female students (as % of total students) of Primary education in 1987 and the Female students (as % of total students) of Secondary vocational education in 1988?
Keep it short and to the point. 17.23. What is the difference between the Female students (as % of total students) of Tertiary education in 1987 and the Female students (as % of total students) of Secondary general education in 1988?
Make the answer very short. -1.25. What is the difference between the Female students (as % of total students) in Tertiary education in 1987 and the Female students (as % of total students) in Secondary vocational education in 1988?
Provide a succinct answer. 10.93. What is the difference between the Female students (as % of total students) in Secondary general education in 1987 and the Female students (as % of total students) in Secondary vocational education in 1988?
Your response must be concise. 11.87. What is the average Female students (as % of total students) in Primary education per year?
Make the answer very short. 44.95. What is the average Female students (as % of total students) of Tertiary education per year?
Your answer should be compact. 38.59. What is the average Female students (as % of total students) in Secondary general education per year?
Provide a short and direct response. 39.46. What is the average Female students (as % of total students) in Secondary vocational education per year?
Provide a short and direct response. 25.66. In the year 1981, what is the difference between the Female students (as % of total students) in Primary education and Female students (as % of total students) in Tertiary education?
Your response must be concise. 6.36. In the year 1981, what is the difference between the Female students (as % of total students) in Primary education and Female students (as % of total students) in Secondary general education?
Your answer should be compact. 6.01. In the year 1981, what is the difference between the Female students (as % of total students) of Primary education and Female students (as % of total students) of Secondary vocational education?
Your answer should be compact. 14.08. In the year 1981, what is the difference between the Female students (as % of total students) in Tertiary education and Female students (as % of total students) in Secondary general education?
Your answer should be compact. -0.35. In the year 1981, what is the difference between the Female students (as % of total students) in Tertiary education and Female students (as % of total students) in Secondary vocational education?
Offer a very short reply. 7.73. In the year 1981, what is the difference between the Female students (as % of total students) of Secondary general education and Female students (as % of total students) of Secondary vocational education?
Your response must be concise. 8.08. In the year 1982, what is the difference between the Female students (as % of total students) of Primary education and Female students (as % of total students) of Tertiary education?
Give a very brief answer. 6.72. In the year 1982, what is the difference between the Female students (as % of total students) of Primary education and Female students (as % of total students) of Secondary general education?
Provide a succinct answer. 6.04. In the year 1982, what is the difference between the Female students (as % of total students) in Primary education and Female students (as % of total students) in Secondary vocational education?
Give a very brief answer. 18.53. In the year 1982, what is the difference between the Female students (as % of total students) in Tertiary education and Female students (as % of total students) in Secondary general education?
Provide a short and direct response. -0.68. In the year 1982, what is the difference between the Female students (as % of total students) in Tertiary education and Female students (as % of total students) in Secondary vocational education?
Ensure brevity in your answer.  11.81. In the year 1982, what is the difference between the Female students (as % of total students) in Secondary general education and Female students (as % of total students) in Secondary vocational education?
Provide a succinct answer. 12.49. In the year 1983, what is the difference between the Female students (as % of total students) of Primary education and Female students (as % of total students) of Tertiary education?
Offer a terse response. 6.62. In the year 1983, what is the difference between the Female students (as % of total students) of Primary education and Female students (as % of total students) of Secondary general education?
Provide a short and direct response. 5.7. In the year 1983, what is the difference between the Female students (as % of total students) in Primary education and Female students (as % of total students) in Secondary vocational education?
Ensure brevity in your answer.  20.1. In the year 1983, what is the difference between the Female students (as % of total students) in Tertiary education and Female students (as % of total students) in Secondary general education?
Your answer should be compact. -0.91. In the year 1983, what is the difference between the Female students (as % of total students) of Tertiary education and Female students (as % of total students) of Secondary vocational education?
Provide a short and direct response. 13.48. In the year 1983, what is the difference between the Female students (as % of total students) of Secondary general education and Female students (as % of total students) of Secondary vocational education?
Provide a short and direct response. 14.4. In the year 1984, what is the difference between the Female students (as % of total students) in Primary education and Female students (as % of total students) in Tertiary education?
Your response must be concise. 6.65. In the year 1984, what is the difference between the Female students (as % of total students) in Primary education and Female students (as % of total students) in Secondary general education?
Your answer should be compact. 5.45. In the year 1984, what is the difference between the Female students (as % of total students) in Primary education and Female students (as % of total students) in Secondary vocational education?
Your response must be concise. 22.27. In the year 1984, what is the difference between the Female students (as % of total students) of Tertiary education and Female students (as % of total students) of Secondary general education?
Provide a succinct answer. -1.2. In the year 1984, what is the difference between the Female students (as % of total students) in Tertiary education and Female students (as % of total students) in Secondary vocational education?
Offer a very short reply. 15.63. In the year 1984, what is the difference between the Female students (as % of total students) of Secondary general education and Female students (as % of total students) of Secondary vocational education?
Keep it short and to the point. 16.83. In the year 1985, what is the difference between the Female students (as % of total students) in Primary education and Female students (as % of total students) in Tertiary education?
Provide a succinct answer. 6.25. In the year 1985, what is the difference between the Female students (as % of total students) of Primary education and Female students (as % of total students) of Secondary general education?
Offer a terse response. 5.13. In the year 1985, what is the difference between the Female students (as % of total students) in Primary education and Female students (as % of total students) in Secondary vocational education?
Give a very brief answer. 20.95. In the year 1985, what is the difference between the Female students (as % of total students) in Tertiary education and Female students (as % of total students) in Secondary general education?
Your answer should be compact. -1.12. In the year 1985, what is the difference between the Female students (as % of total students) in Tertiary education and Female students (as % of total students) in Secondary vocational education?
Your response must be concise. 14.7. In the year 1985, what is the difference between the Female students (as % of total students) of Secondary general education and Female students (as % of total students) of Secondary vocational education?
Your answer should be very brief. 15.83. In the year 1986, what is the difference between the Female students (as % of total students) in Primary education and Female students (as % of total students) in Tertiary education?
Provide a succinct answer. 6.05. In the year 1986, what is the difference between the Female students (as % of total students) of Primary education and Female students (as % of total students) of Secondary general education?
Offer a very short reply. 5.06. In the year 1986, what is the difference between the Female students (as % of total students) in Primary education and Female students (as % of total students) in Secondary vocational education?
Offer a terse response. 20.6. In the year 1986, what is the difference between the Female students (as % of total students) of Tertiary education and Female students (as % of total students) of Secondary general education?
Your answer should be very brief. -0.99. In the year 1986, what is the difference between the Female students (as % of total students) in Tertiary education and Female students (as % of total students) in Secondary vocational education?
Keep it short and to the point. 14.54. In the year 1986, what is the difference between the Female students (as % of total students) of Secondary general education and Female students (as % of total students) of Secondary vocational education?
Your answer should be compact. 15.53. In the year 1987, what is the difference between the Female students (as % of total students) of Primary education and Female students (as % of total students) of Tertiary education?
Your response must be concise. 6.31. In the year 1987, what is the difference between the Female students (as % of total students) of Primary education and Female students (as % of total students) of Secondary general education?
Your answer should be very brief. 5.37. In the year 1987, what is the difference between the Female students (as % of total students) of Primary education and Female students (as % of total students) of Secondary vocational education?
Your response must be concise. 20.48. In the year 1987, what is the difference between the Female students (as % of total students) in Tertiary education and Female students (as % of total students) in Secondary general education?
Ensure brevity in your answer.  -0.94. In the year 1987, what is the difference between the Female students (as % of total students) in Tertiary education and Female students (as % of total students) in Secondary vocational education?
Offer a very short reply. 14.18. In the year 1987, what is the difference between the Female students (as % of total students) in Secondary general education and Female students (as % of total students) in Secondary vocational education?
Provide a short and direct response. 15.11. In the year 1988, what is the difference between the Female students (as % of total students) of Primary education and Female students (as % of total students) of Tertiary education?
Your response must be concise. 5.89. In the year 1988, what is the difference between the Female students (as % of total students) in Primary education and Female students (as % of total students) in Secondary general education?
Your response must be concise. 5.15. In the year 1988, what is the difference between the Female students (as % of total students) of Primary education and Female students (as % of total students) of Secondary vocational education?
Your response must be concise. 17.32. In the year 1988, what is the difference between the Female students (as % of total students) in Tertiary education and Female students (as % of total students) in Secondary general education?
Make the answer very short. -0.74. In the year 1988, what is the difference between the Female students (as % of total students) of Tertiary education and Female students (as % of total students) of Secondary vocational education?
Make the answer very short. 11.43. In the year 1988, what is the difference between the Female students (as % of total students) of Secondary general education and Female students (as % of total students) of Secondary vocational education?
Provide a succinct answer. 12.18. What is the ratio of the Female students (as % of total students) in Primary education in 1981 to that in 1982?
Provide a succinct answer. 0.98. What is the ratio of the Female students (as % of total students) of Tertiary education in 1981 to that in 1982?
Provide a succinct answer. 0.99. What is the ratio of the Female students (as % of total students) in Secondary general education in 1981 to that in 1982?
Offer a terse response. 0.98. What is the ratio of the Female students (as % of total students) in Secondary vocational education in 1981 to that in 1982?
Give a very brief answer. 1.15. What is the ratio of the Female students (as % of total students) in Primary education in 1981 to that in 1983?
Provide a succinct answer. 0.97. What is the ratio of the Female students (as % of total students) in Tertiary education in 1981 to that in 1983?
Your response must be concise. 0.97. What is the ratio of the Female students (as % of total students) in Secondary vocational education in 1981 to that in 1983?
Provide a succinct answer. 1.2. What is the ratio of the Female students (as % of total students) in Primary education in 1981 to that in 1984?
Make the answer very short. 0.96. What is the ratio of the Female students (as % of total students) of Tertiary education in 1981 to that in 1984?
Give a very brief answer. 0.96. What is the ratio of the Female students (as % of total students) of Secondary general education in 1981 to that in 1984?
Provide a succinct answer. 0.94. What is the ratio of the Female students (as % of total students) of Secondary vocational education in 1981 to that in 1984?
Offer a terse response. 1.28. What is the ratio of the Female students (as % of total students) of Primary education in 1981 to that in 1985?
Your answer should be very brief. 0.95. What is the ratio of the Female students (as % of total students) of Tertiary education in 1981 to that in 1985?
Provide a succinct answer. 0.93. What is the ratio of the Female students (as % of total students) in Secondary general education in 1981 to that in 1985?
Provide a succinct answer. 0.92. What is the ratio of the Female students (as % of total students) of Secondary vocational education in 1981 to that in 1985?
Give a very brief answer. 1.18. What is the ratio of the Female students (as % of total students) of Primary education in 1981 to that in 1986?
Make the answer very short. 0.94. What is the ratio of the Female students (as % of total students) in Tertiary education in 1981 to that in 1986?
Keep it short and to the point. 0.92. What is the ratio of the Female students (as % of total students) of Secondary general education in 1981 to that in 1986?
Give a very brief answer. 0.9. What is the ratio of the Female students (as % of total students) in Secondary vocational education in 1981 to that in 1986?
Provide a succinct answer. 1.14. What is the ratio of the Female students (as % of total students) of Primary education in 1981 to that in 1987?
Ensure brevity in your answer.  0.93. What is the ratio of the Female students (as % of total students) in Tertiary education in 1981 to that in 1987?
Your answer should be very brief. 0.91. What is the ratio of the Female students (as % of total students) of Secondary general education in 1981 to that in 1987?
Keep it short and to the point. 0.9. What is the ratio of the Female students (as % of total students) of Secondary vocational education in 1981 to that in 1987?
Provide a short and direct response. 1.12. What is the ratio of the Female students (as % of total students) of Primary education in 1981 to that in 1988?
Your answer should be very brief. 0.93. What is the ratio of the Female students (as % of total students) in Tertiary education in 1981 to that in 1988?
Your answer should be compact. 0.9. What is the ratio of the Female students (as % of total students) of Secondary general education in 1981 to that in 1988?
Your response must be concise. 0.9. What is the ratio of the Female students (as % of total students) of Secondary vocational education in 1981 to that in 1988?
Your answer should be very brief. 0.99. What is the ratio of the Female students (as % of total students) in Primary education in 1982 to that in 1983?
Give a very brief answer. 0.99. What is the ratio of the Female students (as % of total students) of Tertiary education in 1982 to that in 1983?
Your answer should be compact. 0.98. What is the ratio of the Female students (as % of total students) of Secondary vocational education in 1982 to that in 1983?
Your answer should be compact. 1.04. What is the ratio of the Female students (as % of total students) in Primary education in 1982 to that in 1984?
Your answer should be very brief. 0.97. What is the ratio of the Female students (as % of total students) of Tertiary education in 1982 to that in 1984?
Keep it short and to the point. 0.97. What is the ratio of the Female students (as % of total students) in Secondary general education in 1982 to that in 1984?
Your answer should be very brief. 0.96. What is the ratio of the Female students (as % of total students) of Secondary vocational education in 1982 to that in 1984?
Offer a terse response. 1.12. What is the ratio of the Female students (as % of total students) of Primary education in 1982 to that in 1985?
Ensure brevity in your answer.  0.96. What is the ratio of the Female students (as % of total students) in Tertiary education in 1982 to that in 1985?
Keep it short and to the point. 0.95. What is the ratio of the Female students (as % of total students) of Secondary general education in 1982 to that in 1985?
Offer a terse response. 0.94. What is the ratio of the Female students (as % of total students) of Secondary vocational education in 1982 to that in 1985?
Offer a very short reply. 1.03. What is the ratio of the Female students (as % of total students) in Primary education in 1982 to that in 1986?
Make the answer very short. 0.95. What is the ratio of the Female students (as % of total students) of Tertiary education in 1982 to that in 1986?
Make the answer very short. 0.93. What is the ratio of the Female students (as % of total students) of Secondary general education in 1982 to that in 1986?
Provide a succinct answer. 0.92. What is the ratio of the Female students (as % of total students) of Secondary vocational education in 1982 to that in 1986?
Make the answer very short. 1. What is the ratio of the Female students (as % of total students) in Primary education in 1982 to that in 1987?
Give a very brief answer. 0.94. What is the ratio of the Female students (as % of total students) of Tertiary education in 1982 to that in 1987?
Make the answer very short. 0.92. What is the ratio of the Female students (as % of total students) in Secondary general education in 1982 to that in 1987?
Your answer should be compact. 0.92. What is the ratio of the Female students (as % of total students) in Secondary vocational education in 1982 to that in 1987?
Your response must be concise. 0.98. What is the ratio of the Female students (as % of total students) in Primary education in 1982 to that in 1988?
Your answer should be very brief. 0.94. What is the ratio of the Female students (as % of total students) in Tertiary education in 1982 to that in 1988?
Offer a terse response. 0.91. What is the ratio of the Female students (as % of total students) of Secondary general education in 1982 to that in 1988?
Your answer should be very brief. 0.91. What is the ratio of the Female students (as % of total students) of Secondary vocational education in 1982 to that in 1988?
Your answer should be very brief. 0.87. What is the ratio of the Female students (as % of total students) of Primary education in 1983 to that in 1984?
Make the answer very short. 0.99. What is the ratio of the Female students (as % of total students) in Tertiary education in 1983 to that in 1984?
Offer a very short reply. 0.98. What is the ratio of the Female students (as % of total students) in Secondary general education in 1983 to that in 1984?
Offer a terse response. 0.98. What is the ratio of the Female students (as % of total students) of Secondary vocational education in 1983 to that in 1984?
Your answer should be compact. 1.07. What is the ratio of the Female students (as % of total students) of Primary education in 1983 to that in 1985?
Offer a very short reply. 0.97. What is the ratio of the Female students (as % of total students) of Tertiary education in 1983 to that in 1985?
Provide a short and direct response. 0.96. What is the ratio of the Female students (as % of total students) in Secondary general education in 1983 to that in 1985?
Offer a very short reply. 0.96. What is the ratio of the Female students (as % of total students) in Primary education in 1983 to that in 1986?
Keep it short and to the point. 0.96. What is the ratio of the Female students (as % of total students) of Tertiary education in 1983 to that in 1986?
Your response must be concise. 0.94. What is the ratio of the Female students (as % of total students) in Secondary general education in 1983 to that in 1986?
Give a very brief answer. 0.94. What is the ratio of the Female students (as % of total students) in Secondary vocational education in 1983 to that in 1986?
Ensure brevity in your answer.  0.95. What is the ratio of the Female students (as % of total students) of Primary education in 1983 to that in 1987?
Your answer should be very brief. 0.96. What is the ratio of the Female students (as % of total students) of Tertiary education in 1983 to that in 1987?
Make the answer very short. 0.94. What is the ratio of the Female students (as % of total students) of Secondary general education in 1983 to that in 1987?
Provide a succinct answer. 0.94. What is the ratio of the Female students (as % of total students) of Secondary vocational education in 1983 to that in 1987?
Your response must be concise. 0.93. What is the ratio of the Female students (as % of total students) in Primary education in 1983 to that in 1988?
Make the answer very short. 0.95. What is the ratio of the Female students (as % of total students) of Secondary general education in 1983 to that in 1988?
Keep it short and to the point. 0.93. What is the ratio of the Female students (as % of total students) in Secondary vocational education in 1983 to that in 1988?
Your response must be concise. 0.83. What is the ratio of the Female students (as % of total students) of Primary education in 1984 to that in 1985?
Make the answer very short. 0.99. What is the ratio of the Female students (as % of total students) of Tertiary education in 1984 to that in 1985?
Your response must be concise. 0.98. What is the ratio of the Female students (as % of total students) of Secondary general education in 1984 to that in 1985?
Keep it short and to the point. 0.98. What is the ratio of the Female students (as % of total students) of Secondary vocational education in 1984 to that in 1985?
Provide a short and direct response. 0.92. What is the ratio of the Female students (as % of total students) of Primary education in 1984 to that in 1986?
Make the answer very short. 0.98. What is the ratio of the Female students (as % of total students) of Tertiary education in 1984 to that in 1986?
Your answer should be very brief. 0.96. What is the ratio of the Female students (as % of total students) of Secondary general education in 1984 to that in 1986?
Offer a terse response. 0.97. What is the ratio of the Female students (as % of total students) in Secondary vocational education in 1984 to that in 1986?
Offer a terse response. 0.89. What is the ratio of the Female students (as % of total students) of Primary education in 1984 to that in 1987?
Your response must be concise. 0.97. What is the ratio of the Female students (as % of total students) of Tertiary education in 1984 to that in 1987?
Make the answer very short. 0.95. What is the ratio of the Female students (as % of total students) in Secondary general education in 1984 to that in 1987?
Keep it short and to the point. 0.96. What is the ratio of the Female students (as % of total students) in Secondary vocational education in 1984 to that in 1987?
Provide a succinct answer. 0.87. What is the ratio of the Female students (as % of total students) of Primary education in 1984 to that in 1988?
Your response must be concise. 0.97. What is the ratio of the Female students (as % of total students) of Tertiary education in 1984 to that in 1988?
Your answer should be very brief. 0.94. What is the ratio of the Female students (as % of total students) of Secondary general education in 1984 to that in 1988?
Provide a succinct answer. 0.96. What is the ratio of the Female students (as % of total students) in Secondary vocational education in 1984 to that in 1988?
Provide a succinct answer. 0.78. What is the ratio of the Female students (as % of total students) in Primary education in 1985 to that in 1986?
Ensure brevity in your answer.  0.99. What is the ratio of the Female students (as % of total students) of Tertiary education in 1985 to that in 1986?
Ensure brevity in your answer.  0.98. What is the ratio of the Female students (as % of total students) of Secondary general education in 1985 to that in 1986?
Offer a terse response. 0.99. What is the ratio of the Female students (as % of total students) of Secondary vocational education in 1985 to that in 1986?
Provide a short and direct response. 0.97. What is the ratio of the Female students (as % of total students) of Primary education in 1985 to that in 1987?
Your response must be concise. 0.98. What is the ratio of the Female students (as % of total students) in Tertiary education in 1985 to that in 1987?
Ensure brevity in your answer.  0.98. What is the ratio of the Female students (as % of total students) in Secondary general education in 1985 to that in 1987?
Make the answer very short. 0.98. What is the ratio of the Female students (as % of total students) in Secondary vocational education in 1985 to that in 1987?
Your answer should be very brief. 0.95. What is the ratio of the Female students (as % of total students) of Primary education in 1985 to that in 1988?
Offer a terse response. 0.98. What is the ratio of the Female students (as % of total students) of Secondary general education in 1985 to that in 1988?
Offer a terse response. 0.98. What is the ratio of the Female students (as % of total students) of Secondary vocational education in 1985 to that in 1988?
Your response must be concise. 0.84. What is the ratio of the Female students (as % of total students) of Secondary vocational education in 1986 to that in 1987?
Ensure brevity in your answer.  0.98. What is the ratio of the Female students (as % of total students) of Secondary general education in 1986 to that in 1988?
Provide a short and direct response. 0.99. What is the ratio of the Female students (as % of total students) of Secondary vocational education in 1986 to that in 1988?
Your response must be concise. 0.87. What is the ratio of the Female students (as % of total students) of Primary education in 1987 to that in 1988?
Ensure brevity in your answer.  1. What is the ratio of the Female students (as % of total students) in Tertiary education in 1987 to that in 1988?
Your answer should be compact. 0.99. What is the ratio of the Female students (as % of total students) of Secondary general education in 1987 to that in 1988?
Your answer should be compact. 0.99. What is the ratio of the Female students (as % of total students) of Secondary vocational education in 1987 to that in 1988?
Your response must be concise. 0.89. What is the difference between the highest and the second highest Female students (as % of total students) in Primary education?
Offer a very short reply. 0.09. What is the difference between the highest and the second highest Female students (as % of total students) in Tertiary education?
Give a very brief answer. 0.5. What is the difference between the highest and the second highest Female students (as % of total students) of Secondary general education?
Provide a short and direct response. 0.31. What is the difference between the highest and the second highest Female students (as % of total students) of Secondary vocational education?
Give a very brief answer. 0.23. What is the difference between the highest and the lowest Female students (as % of total students) in Primary education?
Your answer should be compact. 3.47. What is the difference between the highest and the lowest Female students (as % of total students) in Tertiary education?
Make the answer very short. 3.94. What is the difference between the highest and the lowest Female students (as % of total students) in Secondary general education?
Your answer should be compact. 4.33. What is the difference between the highest and the lowest Female students (as % of total students) of Secondary vocational education?
Offer a very short reply. 6.5. 